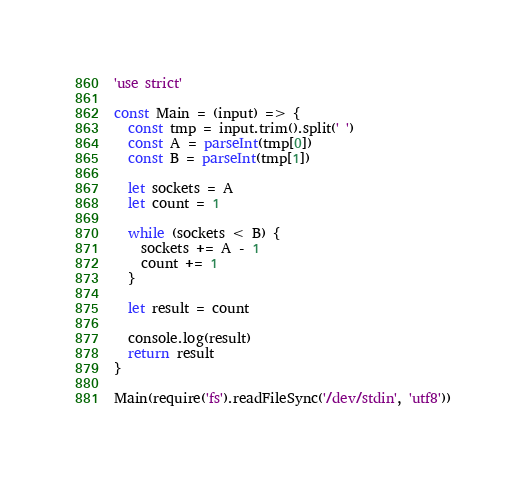Convert code to text. <code><loc_0><loc_0><loc_500><loc_500><_JavaScript_>'use strict'

const Main = (input) => {
  const tmp = input.trim().split(' ')
  const A = parseInt(tmp[0])
  const B = parseInt(tmp[1])

  let sockets = A
  let count = 1

  while (sockets < B) {
    sockets += A - 1
    count += 1
  }

  let result = count

  console.log(result)
  return result
}

Main(require('fs').readFileSync('/dev/stdin', 'utf8'))</code> 